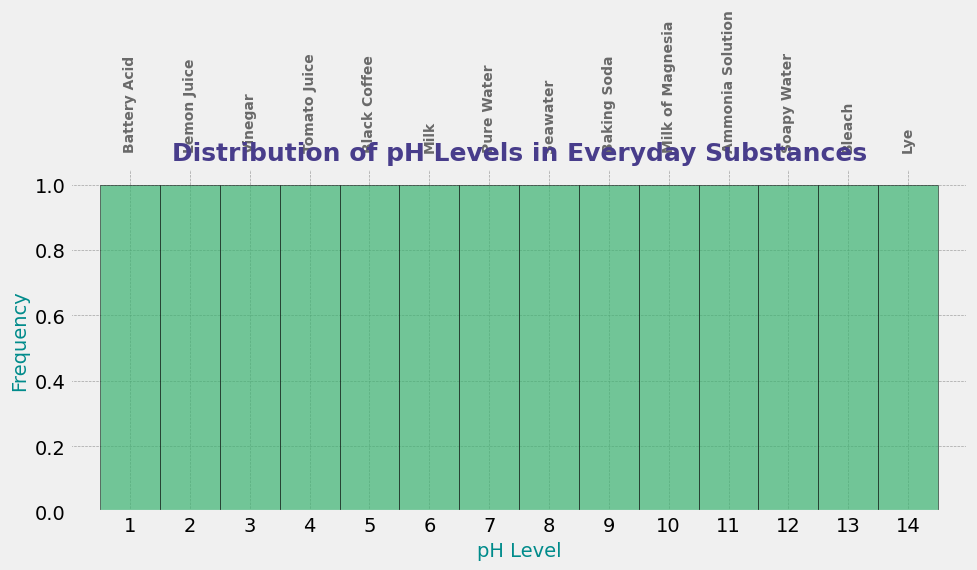Which substance has the highest pH level? Look at the figure and identify the bar that is furthest to the right. The label on this bar indicates "Lye," which is associated with the highest pH level.
Answer: Lye Which substance has a pH level that is neutral? Identify the bar at pH=7 on the x-axis. The label on this bar indicates "Pure Water," meaning it has a neutral pH level.
Answer: Pure Water How many substances have a pH level less than 7? Count the number of bars that appear on the left side of the figure up to pH=6. These bars include Battery Acid, Lemon Juice, Vinegar, Tomato Juice, Black Coffee, Milk.
Answer: 6 Which substances are more alkaline than Soapy Water? Find the bar for Soapy Water, which is at pH=12, then identify all bars to the right of this, which are Bleach and Lye.
Answer: Bleach and Lye Compare the pH levels of Seawater and Black Coffee. Which one is more acidic? Locate the bars for Seawater (pH=8) and Black Coffee (pH=5). Since a lower pH indicates higher acidity, Black Coffee is more acidic.
Answer: Black Coffee What is the mean pH level of the substances that are alkaline? Identify the pH levels greater than 7 (Seawater, Baking Soda, Milk of Magnesia, Ammonia Solution, Soapy Water, Bleach, Lye). Calculate the mean by summing these values (8+9+10+11+12+13+14) and dividing by the number of substances (7). The calculation is (8+9+10+11+12+13+14)/7 = 11.
Answer: 11 Is Pure Water more acidic than Black Coffee? Compare the positions of the bars for Pure Water (pH=7) and Black Coffee (pH=5) on the x-axis. Since 5 is less than 7, Black Coffee is more acidic.
Answer: No Which substance has a pH level closest to that of Baking Soda? Identify the bar for Baking Soda (pH=9). Then, check adjacent bars. Milk of Magnesia is at pH=10, which is the closest.
Answer: Milk of Magnesia How many substances are more acidic than Tomato Juice? Locate the bar for Tomato Juice (pH=4). Count the bars to the left of this, which are Battery Acid, Lemon Juice, and Vinegar.
Answer: 3 What is the range of pH levels for the substances shown? Identify the lowest and highest pH levels in the figure. The lowest is for Battery Acid at pH=1 and the highest is for Lye at pH=14. The range is the difference between the highest and lowest values, i.e., 14-1.
Answer: 13 